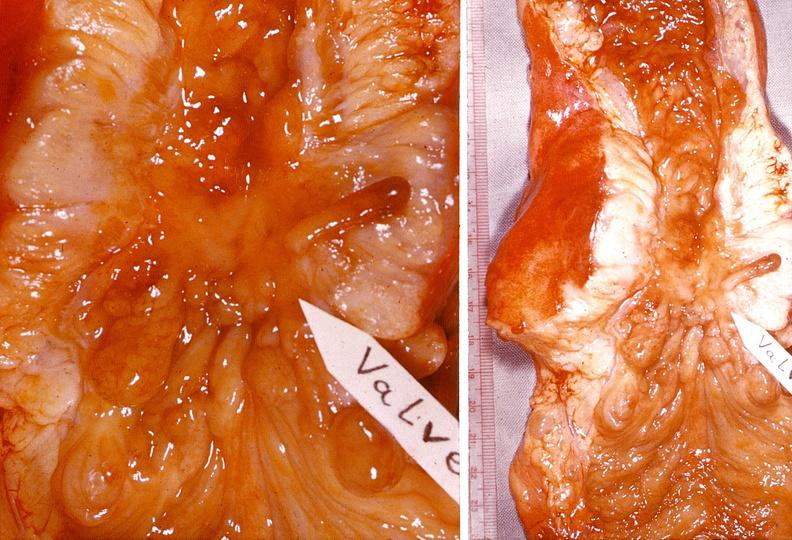does fallopian tube show small intestine, regional enteritis?
Answer the question using a single word or phrase. No 